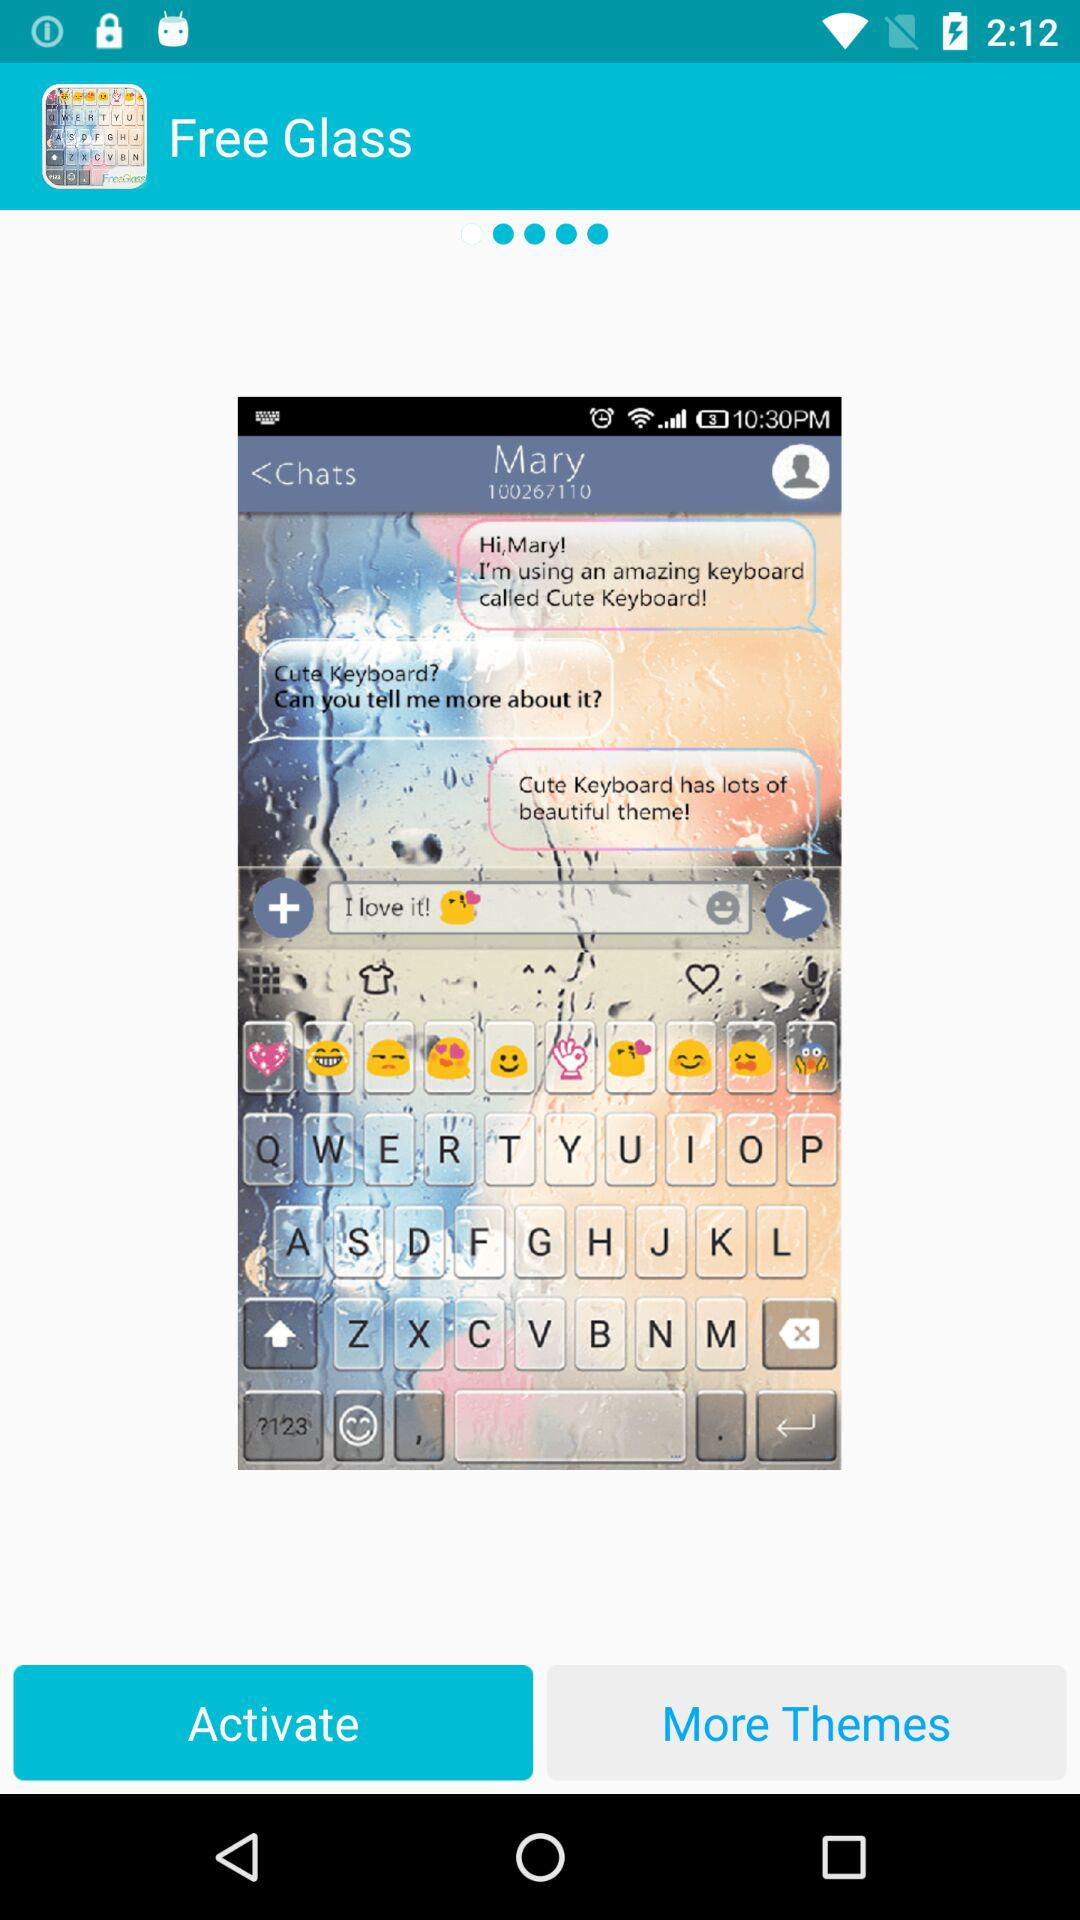What is the name of the application? The name of the application is "Free Glass". 